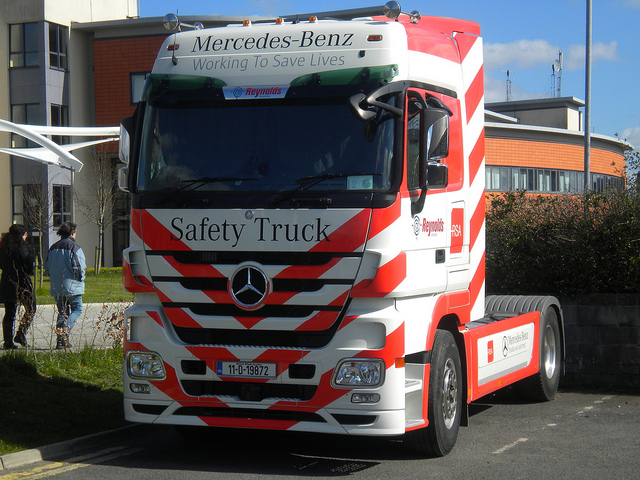Extract all visible text content from this image. Mercedes- Benz Working To Save Lives Res Reynolds 19872 0 11 Truck Safety 